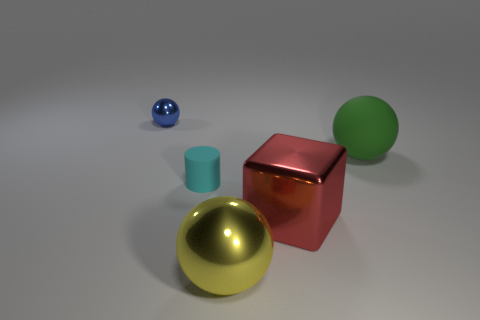How many blue metallic things are the same size as the matte cylinder?
Give a very brief answer. 1. There is another sphere that is the same size as the yellow sphere; what is its color?
Make the answer very short. Green. What is the color of the matte sphere?
Give a very brief answer. Green. There is a big yellow ball in front of the green ball; what material is it?
Provide a short and direct response. Metal. The yellow thing that is the same shape as the small blue metal thing is what size?
Your answer should be compact. Large. Are there fewer small balls right of the yellow thing than brown balls?
Provide a succinct answer. No. Are there any tiny cyan things?
Your response must be concise. Yes. What is the color of the other large rubber thing that is the same shape as the large yellow object?
Offer a terse response. Green. Do the green sphere and the blue shiny object have the same size?
Offer a very short reply. No. There is a tiny thing that is made of the same material as the yellow sphere; what is its shape?
Your response must be concise. Sphere. 